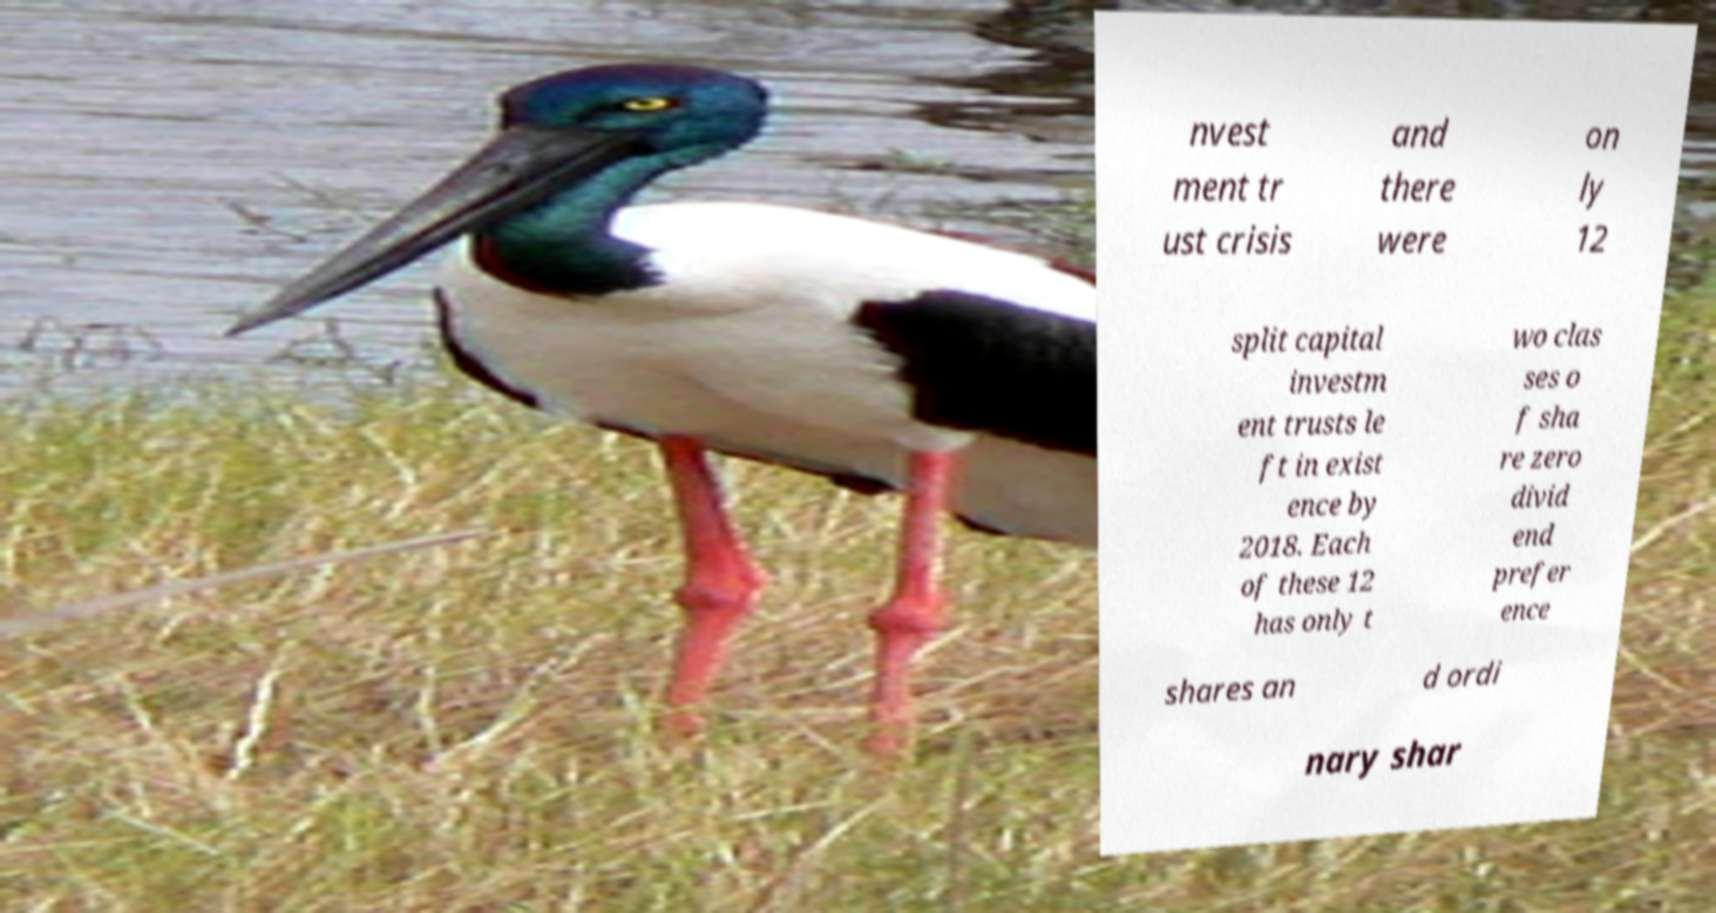I need the written content from this picture converted into text. Can you do that? nvest ment tr ust crisis and there were on ly 12 split capital investm ent trusts le ft in exist ence by 2018. Each of these 12 has only t wo clas ses o f sha re zero divid end prefer ence shares an d ordi nary shar 